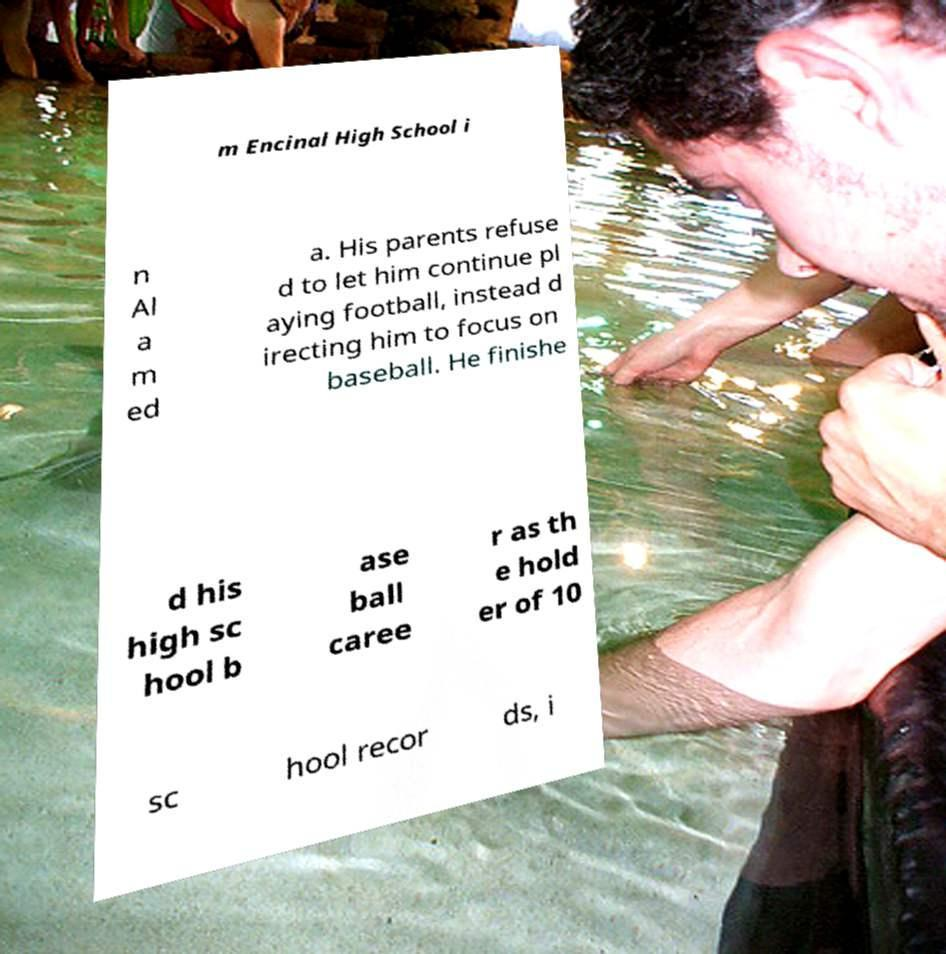I need the written content from this picture converted into text. Can you do that? m Encinal High School i n Al a m ed a. His parents refuse d to let him continue pl aying football, instead d irecting him to focus on baseball. He finishe d his high sc hool b ase ball caree r as th e hold er of 10 sc hool recor ds, i 